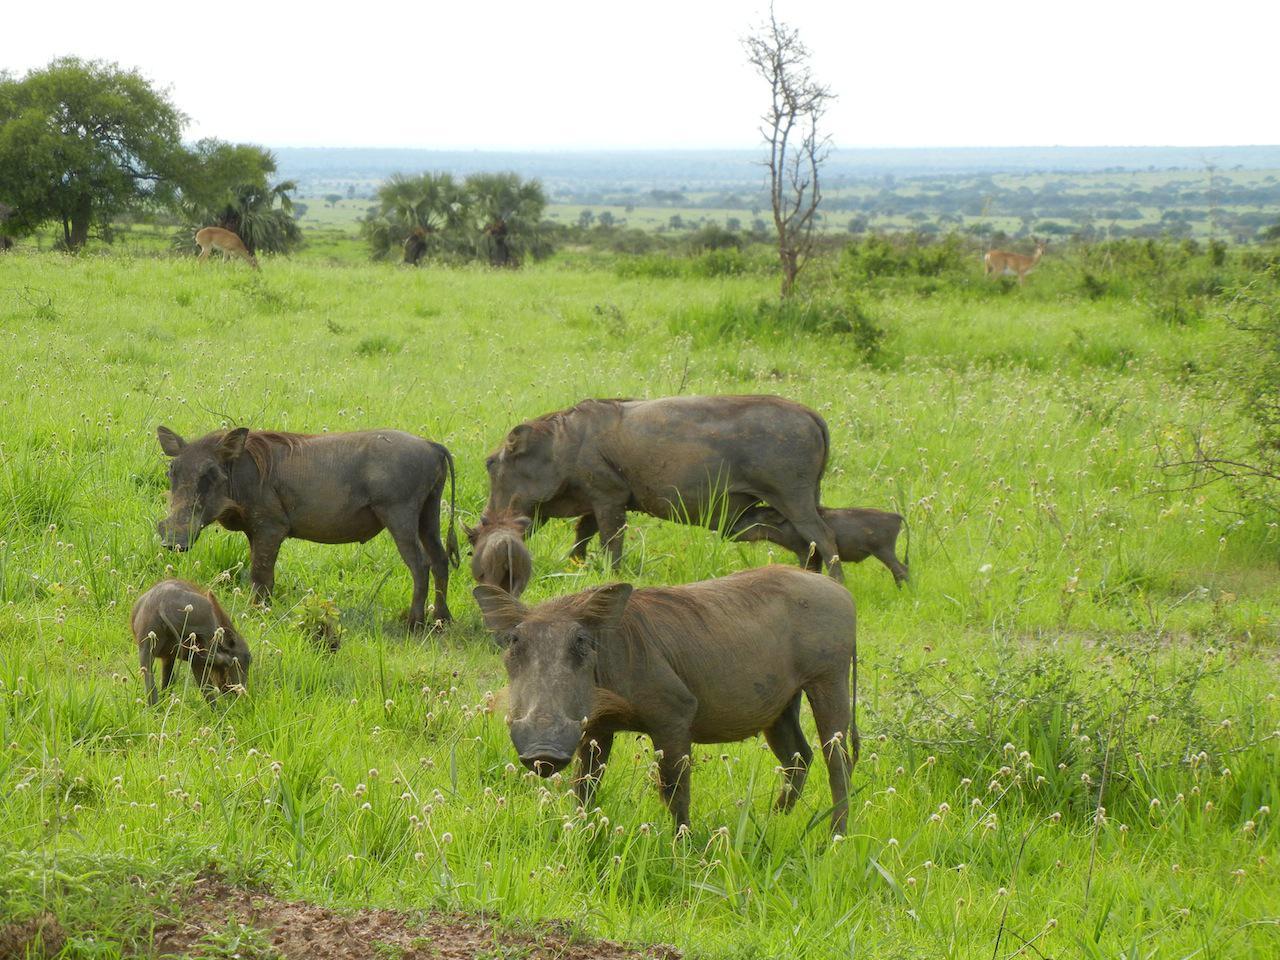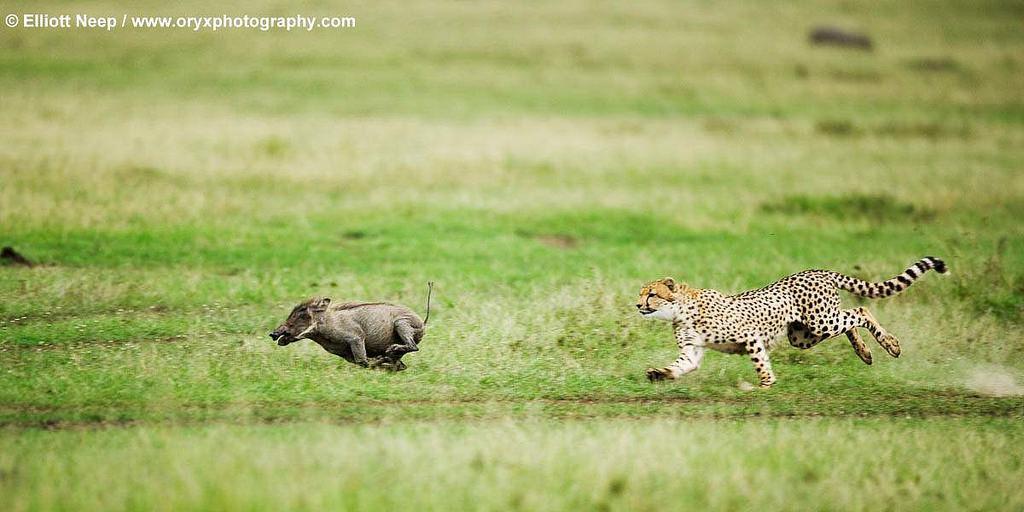The first image is the image on the left, the second image is the image on the right. For the images shown, is this caption "there are three baby animals in the image on the right" true? Answer yes or no. No. The first image is the image on the left, the second image is the image on the right. For the images shown, is this caption "One image includes a predator of the warthog." true? Answer yes or no. Yes. 